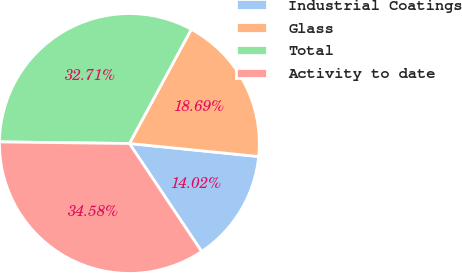<chart> <loc_0><loc_0><loc_500><loc_500><pie_chart><fcel>Industrial Coatings<fcel>Glass<fcel>Total<fcel>Activity to date<nl><fcel>14.02%<fcel>18.69%<fcel>32.71%<fcel>34.58%<nl></chart> 